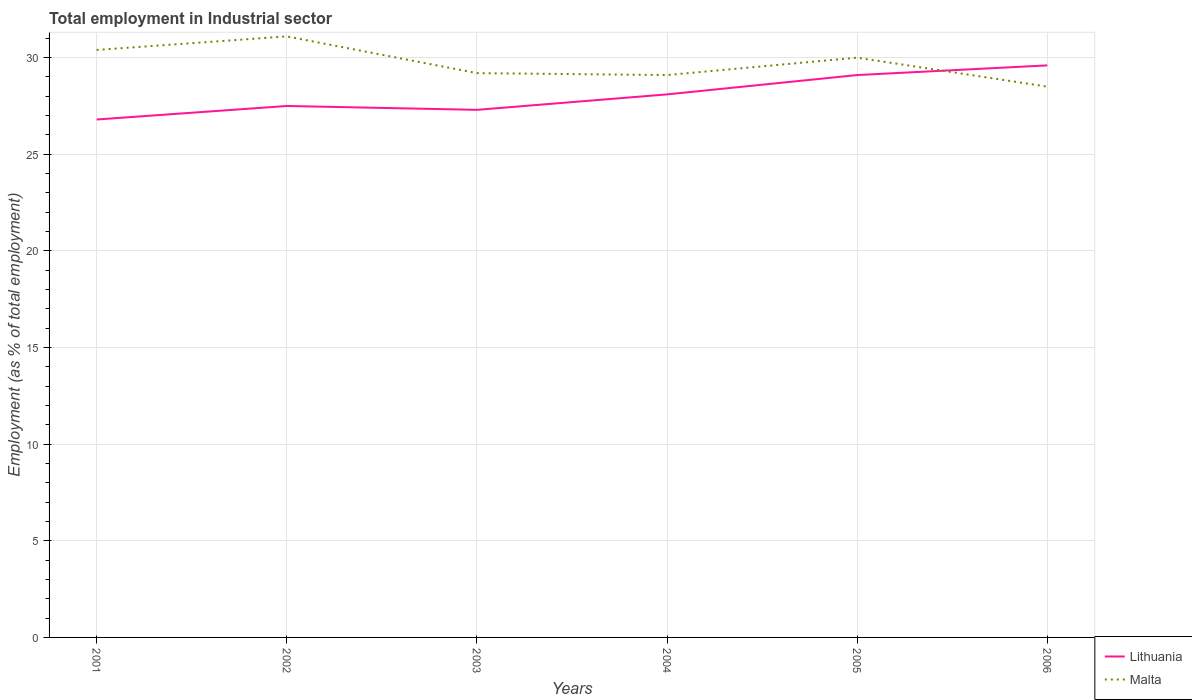How many different coloured lines are there?
Offer a terse response. 2. Across all years, what is the maximum employment in industrial sector in Lithuania?
Provide a succinct answer. 26.8. What is the difference between the highest and the second highest employment in industrial sector in Malta?
Keep it short and to the point. 2.6. What is the difference between the highest and the lowest employment in industrial sector in Lithuania?
Offer a very short reply. 3. How many years are there in the graph?
Your answer should be very brief. 6. What is the difference between two consecutive major ticks on the Y-axis?
Your response must be concise. 5. Does the graph contain grids?
Give a very brief answer. Yes. What is the title of the graph?
Your answer should be very brief. Total employment in Industrial sector. What is the label or title of the Y-axis?
Provide a short and direct response. Employment (as % of total employment). What is the Employment (as % of total employment) in Lithuania in 2001?
Provide a succinct answer. 26.8. What is the Employment (as % of total employment) of Malta in 2001?
Keep it short and to the point. 30.4. What is the Employment (as % of total employment) in Malta in 2002?
Offer a very short reply. 31.1. What is the Employment (as % of total employment) of Lithuania in 2003?
Make the answer very short. 27.3. What is the Employment (as % of total employment) of Malta in 2003?
Keep it short and to the point. 29.2. What is the Employment (as % of total employment) in Lithuania in 2004?
Your answer should be very brief. 28.1. What is the Employment (as % of total employment) in Malta in 2004?
Your answer should be very brief. 29.1. What is the Employment (as % of total employment) of Lithuania in 2005?
Your answer should be compact. 29.1. What is the Employment (as % of total employment) of Malta in 2005?
Ensure brevity in your answer.  30. What is the Employment (as % of total employment) of Lithuania in 2006?
Your answer should be very brief. 29.6. What is the Employment (as % of total employment) of Malta in 2006?
Provide a succinct answer. 28.5. Across all years, what is the maximum Employment (as % of total employment) in Lithuania?
Keep it short and to the point. 29.6. Across all years, what is the maximum Employment (as % of total employment) in Malta?
Your answer should be very brief. 31.1. Across all years, what is the minimum Employment (as % of total employment) of Lithuania?
Your answer should be compact. 26.8. Across all years, what is the minimum Employment (as % of total employment) of Malta?
Ensure brevity in your answer.  28.5. What is the total Employment (as % of total employment) in Lithuania in the graph?
Provide a short and direct response. 168.4. What is the total Employment (as % of total employment) of Malta in the graph?
Keep it short and to the point. 178.3. What is the difference between the Employment (as % of total employment) in Malta in 2001 and that in 2002?
Your response must be concise. -0.7. What is the difference between the Employment (as % of total employment) of Malta in 2001 and that in 2003?
Your answer should be very brief. 1.2. What is the difference between the Employment (as % of total employment) of Malta in 2001 and that in 2004?
Give a very brief answer. 1.3. What is the difference between the Employment (as % of total employment) of Malta in 2001 and that in 2005?
Keep it short and to the point. 0.4. What is the difference between the Employment (as % of total employment) in Lithuania in 2001 and that in 2006?
Keep it short and to the point. -2.8. What is the difference between the Employment (as % of total employment) in Malta in 2001 and that in 2006?
Your answer should be compact. 1.9. What is the difference between the Employment (as % of total employment) in Malta in 2002 and that in 2004?
Make the answer very short. 2. What is the difference between the Employment (as % of total employment) of Lithuania in 2002 and that in 2005?
Keep it short and to the point. -1.6. What is the difference between the Employment (as % of total employment) in Malta in 2002 and that in 2005?
Offer a very short reply. 1.1. What is the difference between the Employment (as % of total employment) in Malta in 2002 and that in 2006?
Your response must be concise. 2.6. What is the difference between the Employment (as % of total employment) in Lithuania in 2003 and that in 2004?
Keep it short and to the point. -0.8. What is the difference between the Employment (as % of total employment) of Malta in 2003 and that in 2004?
Your answer should be compact. 0.1. What is the difference between the Employment (as % of total employment) of Malta in 2003 and that in 2005?
Ensure brevity in your answer.  -0.8. What is the difference between the Employment (as % of total employment) in Lithuania in 2003 and that in 2006?
Offer a very short reply. -2.3. What is the difference between the Employment (as % of total employment) of Malta in 2004 and that in 2006?
Your response must be concise. 0.6. What is the difference between the Employment (as % of total employment) of Lithuania in 2005 and that in 2006?
Offer a very short reply. -0.5. What is the difference between the Employment (as % of total employment) in Malta in 2005 and that in 2006?
Keep it short and to the point. 1.5. What is the difference between the Employment (as % of total employment) of Lithuania in 2001 and the Employment (as % of total employment) of Malta in 2002?
Ensure brevity in your answer.  -4.3. What is the difference between the Employment (as % of total employment) of Lithuania in 2001 and the Employment (as % of total employment) of Malta in 2003?
Your answer should be compact. -2.4. What is the difference between the Employment (as % of total employment) of Lithuania in 2001 and the Employment (as % of total employment) of Malta in 2004?
Offer a very short reply. -2.3. What is the difference between the Employment (as % of total employment) in Lithuania in 2001 and the Employment (as % of total employment) in Malta in 2005?
Your answer should be compact. -3.2. What is the difference between the Employment (as % of total employment) in Lithuania in 2001 and the Employment (as % of total employment) in Malta in 2006?
Your response must be concise. -1.7. What is the difference between the Employment (as % of total employment) in Lithuania in 2002 and the Employment (as % of total employment) in Malta in 2003?
Give a very brief answer. -1.7. What is the difference between the Employment (as % of total employment) of Lithuania in 2002 and the Employment (as % of total employment) of Malta in 2006?
Provide a succinct answer. -1. What is the difference between the Employment (as % of total employment) in Lithuania in 2003 and the Employment (as % of total employment) in Malta in 2006?
Offer a very short reply. -1.2. What is the average Employment (as % of total employment) of Lithuania per year?
Your answer should be very brief. 28.07. What is the average Employment (as % of total employment) of Malta per year?
Offer a very short reply. 29.72. In the year 2001, what is the difference between the Employment (as % of total employment) in Lithuania and Employment (as % of total employment) in Malta?
Make the answer very short. -3.6. In the year 2002, what is the difference between the Employment (as % of total employment) in Lithuania and Employment (as % of total employment) in Malta?
Ensure brevity in your answer.  -3.6. In the year 2003, what is the difference between the Employment (as % of total employment) in Lithuania and Employment (as % of total employment) in Malta?
Make the answer very short. -1.9. In the year 2005, what is the difference between the Employment (as % of total employment) of Lithuania and Employment (as % of total employment) of Malta?
Offer a terse response. -0.9. What is the ratio of the Employment (as % of total employment) in Lithuania in 2001 to that in 2002?
Your response must be concise. 0.97. What is the ratio of the Employment (as % of total employment) of Malta in 2001 to that in 2002?
Give a very brief answer. 0.98. What is the ratio of the Employment (as % of total employment) of Lithuania in 2001 to that in 2003?
Keep it short and to the point. 0.98. What is the ratio of the Employment (as % of total employment) in Malta in 2001 to that in 2003?
Ensure brevity in your answer.  1.04. What is the ratio of the Employment (as % of total employment) of Lithuania in 2001 to that in 2004?
Give a very brief answer. 0.95. What is the ratio of the Employment (as % of total employment) of Malta in 2001 to that in 2004?
Provide a short and direct response. 1.04. What is the ratio of the Employment (as % of total employment) of Lithuania in 2001 to that in 2005?
Offer a terse response. 0.92. What is the ratio of the Employment (as % of total employment) of Malta in 2001 to that in 2005?
Your answer should be compact. 1.01. What is the ratio of the Employment (as % of total employment) in Lithuania in 2001 to that in 2006?
Your answer should be very brief. 0.91. What is the ratio of the Employment (as % of total employment) in Malta in 2001 to that in 2006?
Your answer should be compact. 1.07. What is the ratio of the Employment (as % of total employment) in Lithuania in 2002 to that in 2003?
Give a very brief answer. 1.01. What is the ratio of the Employment (as % of total employment) in Malta in 2002 to that in 2003?
Keep it short and to the point. 1.07. What is the ratio of the Employment (as % of total employment) in Lithuania in 2002 to that in 2004?
Provide a succinct answer. 0.98. What is the ratio of the Employment (as % of total employment) of Malta in 2002 to that in 2004?
Provide a short and direct response. 1.07. What is the ratio of the Employment (as % of total employment) of Lithuania in 2002 to that in 2005?
Make the answer very short. 0.94. What is the ratio of the Employment (as % of total employment) of Malta in 2002 to that in 2005?
Your answer should be compact. 1.04. What is the ratio of the Employment (as % of total employment) in Lithuania in 2002 to that in 2006?
Provide a succinct answer. 0.93. What is the ratio of the Employment (as % of total employment) in Malta in 2002 to that in 2006?
Your response must be concise. 1.09. What is the ratio of the Employment (as % of total employment) in Lithuania in 2003 to that in 2004?
Provide a succinct answer. 0.97. What is the ratio of the Employment (as % of total employment) of Malta in 2003 to that in 2004?
Offer a very short reply. 1. What is the ratio of the Employment (as % of total employment) in Lithuania in 2003 to that in 2005?
Your answer should be very brief. 0.94. What is the ratio of the Employment (as % of total employment) of Malta in 2003 to that in 2005?
Give a very brief answer. 0.97. What is the ratio of the Employment (as % of total employment) of Lithuania in 2003 to that in 2006?
Your answer should be compact. 0.92. What is the ratio of the Employment (as % of total employment) in Malta in 2003 to that in 2006?
Your response must be concise. 1.02. What is the ratio of the Employment (as % of total employment) of Lithuania in 2004 to that in 2005?
Provide a short and direct response. 0.97. What is the ratio of the Employment (as % of total employment) of Lithuania in 2004 to that in 2006?
Make the answer very short. 0.95. What is the ratio of the Employment (as % of total employment) in Malta in 2004 to that in 2006?
Give a very brief answer. 1.02. What is the ratio of the Employment (as % of total employment) of Lithuania in 2005 to that in 2006?
Provide a short and direct response. 0.98. What is the ratio of the Employment (as % of total employment) of Malta in 2005 to that in 2006?
Keep it short and to the point. 1.05. What is the difference between the highest and the lowest Employment (as % of total employment) of Malta?
Provide a short and direct response. 2.6. 